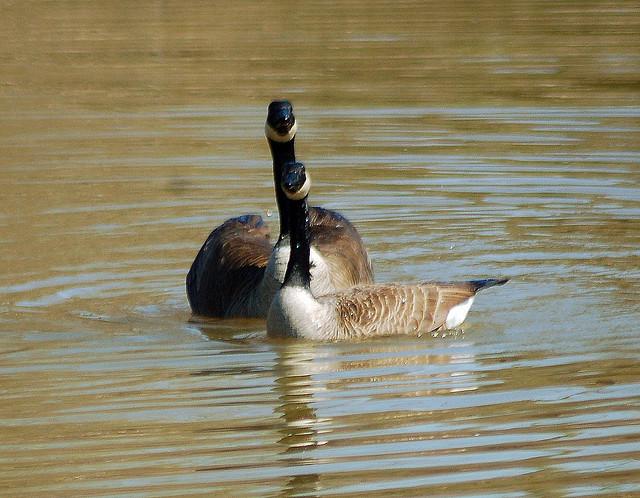Which of the geese is likely to be female?
Keep it brief. Front one. Is the water muddy?
Quick response, please. Yes. How many geese are in the picture?
Keep it brief. 2. How many birds are depicted?
Quick response, please. 2. Are these animals floating or sinking?
Answer briefly. Floating. 